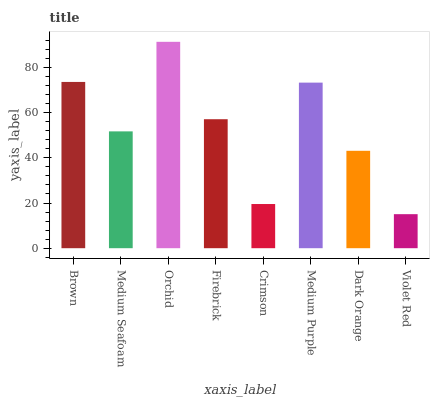Is Violet Red the minimum?
Answer yes or no. Yes. Is Orchid the maximum?
Answer yes or no. Yes. Is Medium Seafoam the minimum?
Answer yes or no. No. Is Medium Seafoam the maximum?
Answer yes or no. No. Is Brown greater than Medium Seafoam?
Answer yes or no. Yes. Is Medium Seafoam less than Brown?
Answer yes or no. Yes. Is Medium Seafoam greater than Brown?
Answer yes or no. No. Is Brown less than Medium Seafoam?
Answer yes or no. No. Is Firebrick the high median?
Answer yes or no. Yes. Is Medium Seafoam the low median?
Answer yes or no. Yes. Is Orchid the high median?
Answer yes or no. No. Is Medium Purple the low median?
Answer yes or no. No. 